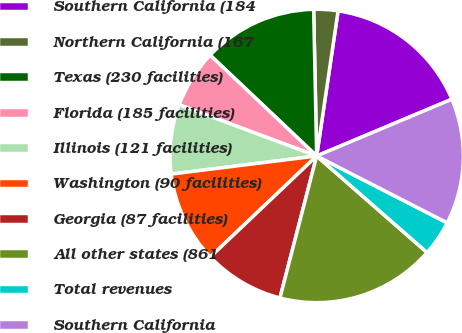Convert chart to OTSL. <chart><loc_0><loc_0><loc_500><loc_500><pie_chart><fcel>Southern California (184<fcel>Northern California (167<fcel>Texas (230 facilities)<fcel>Florida (185 facilities)<fcel>Illinois (121 facilities)<fcel>Washington (90 facilities)<fcel>Georgia (87 facilities)<fcel>All other states (861<fcel>Total revenues<fcel>Southern California<nl><fcel>16.34%<fcel>2.66%<fcel>12.61%<fcel>6.39%<fcel>7.64%<fcel>10.12%<fcel>8.88%<fcel>17.59%<fcel>3.9%<fcel>13.86%<nl></chart> 